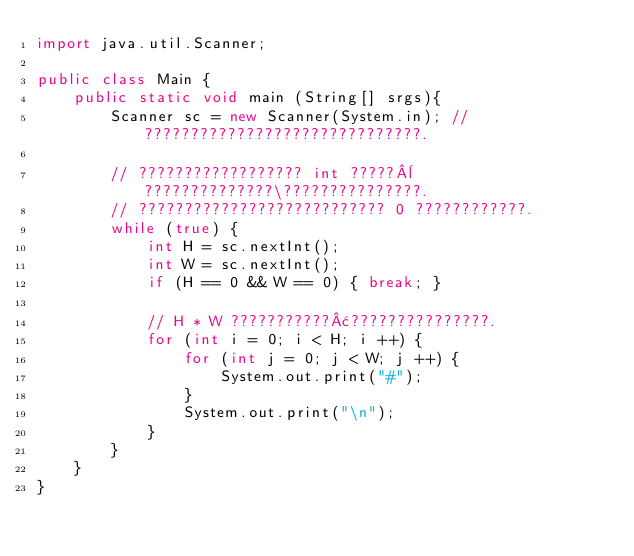Convert code to text. <code><loc_0><loc_0><loc_500><loc_500><_Java_>import java.util.Scanner;

public class Main {
    public static void main (String[] srgs){
        Scanner sc = new Scanner(System.in); // ??????????????????????????????.

        // ?????????????????? int ?????¨??????????????\???????????????.
        // ??????????????????????????? 0 ????????????.
        while (true) {
            int H = sc.nextInt();
            int W = sc.nextInt();
            if (H == 0 && W == 0) { break; }

            // H * W ???????????¢???????????????.
            for (int i = 0; i < H; i ++) {
                for (int j = 0; j < W; j ++) {
                    System.out.print("#");
                }
                System.out.print("\n");
            }
        }
    }
}</code> 